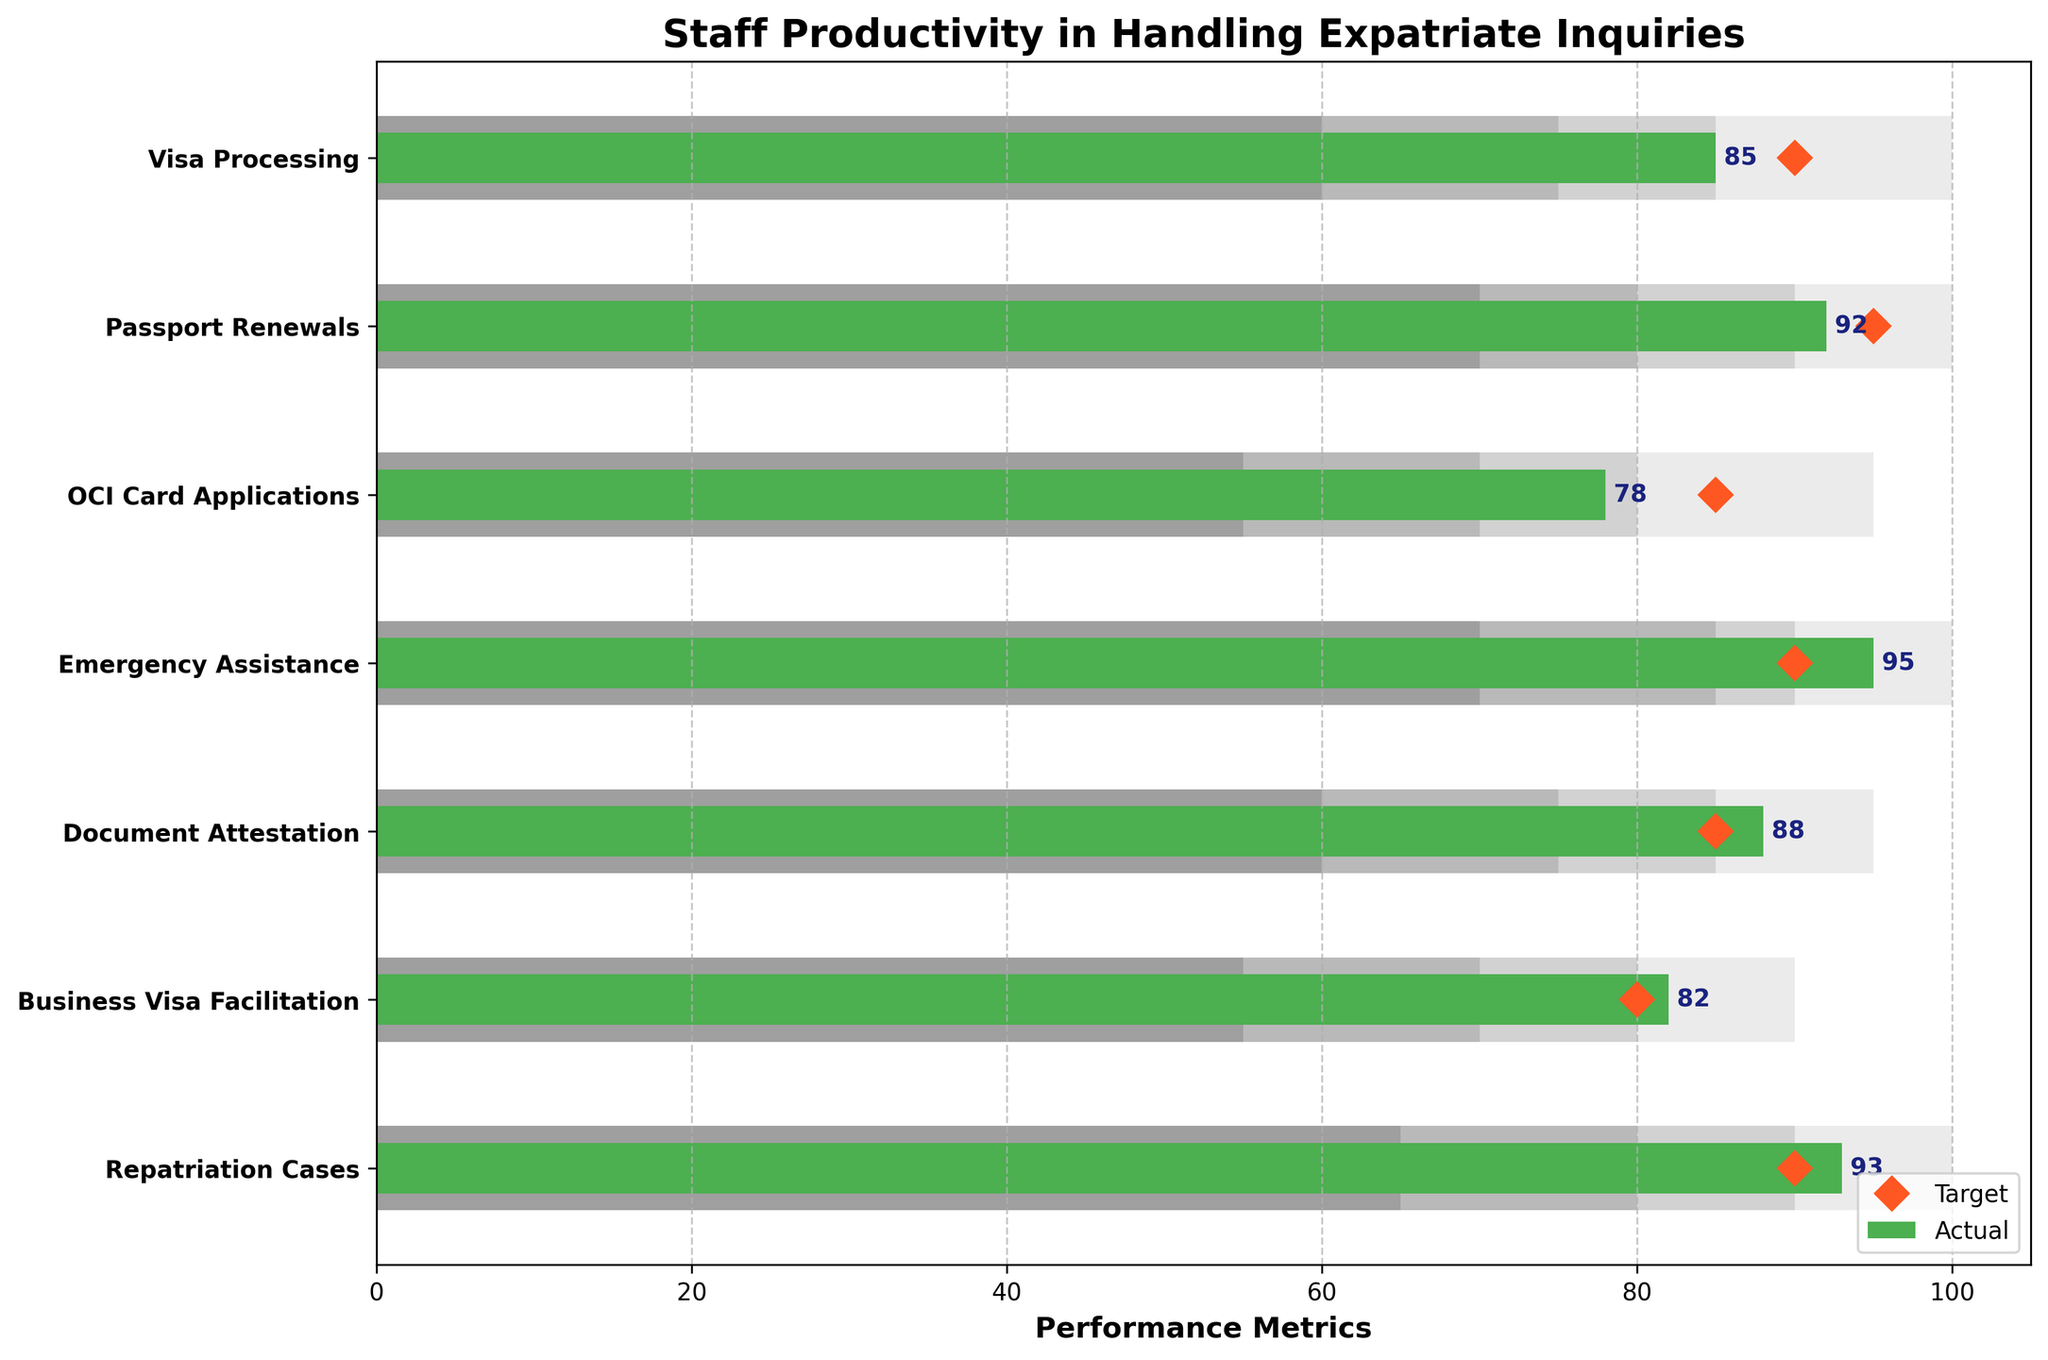How many categories of expatriate inquiries are represented in the chart? There are seven different categories listed on the y-axis of the chart. By counting the labels, we can confirm this.
Answer: Seven What is the target performance for Visa Processing? The target performance for Visa Processing is indicated by the orange diamond marker on the horizontal axis next to Visa Processing. Just locate the diamond and read the value on the x-axis.
Answer: 90 In which category is the staff's actual performance equal to the target performance? By looking at where the green bars end and comparing them to the positions of the orange diamonds, we can see that for Emergency Assistance, the green bar ends exactly where the diamond is.
Answer: Emergency Assistance Which category has the highest actual performance? By examining the length of the green bars, the category with the longest green bar represents the highest performance. We see that Repatriation Cases has the longest green bar.
Answer: Repatriation Cases What is the difference between the actual and target performance for Document Attestation? The actual performance for Document Attestation is 88, and the target is 85. To find the difference, subtract the target performance from the actual performance: 88 - 85.
Answer: 3 Which categories have actual performances that fall within the "Good" performance range? The "Good" performance range is indicated by a specific shade of gray. By looking at where the green bars fall in relation to this background shade, we see that Visa Processing, Emergency Assistance, and Document Attestation fall within the "Good" range.
Answer: Visa Processing, Emergency Assistance, Document Attestation What is the average actual performance across all categories? To find the average actual performance, add up all the actual performance values (85 + 92 + 78 + 95 + 88 + 82 + 93) and then divide by the number of categories (7). The sum is 613, and 613 divided by 7 gives the average.
Answer: 87.57 In which category is the staff’s actual performance the farthest behind the target performance? This requires calculating the difference between the actual and target for each category and finding the maximum negative difference. For OCI Card Applications, the actual is 78 and the target is 85, yielding a difference of -7, which is the largest difference.
Answer: OCI Card Applications What is the total target performance for all categories combined? Sum the target performance values for each category: 90 + 95 + 85 + 90 + 85 + 80 + 90. The sum is 615.
Answer: 615 